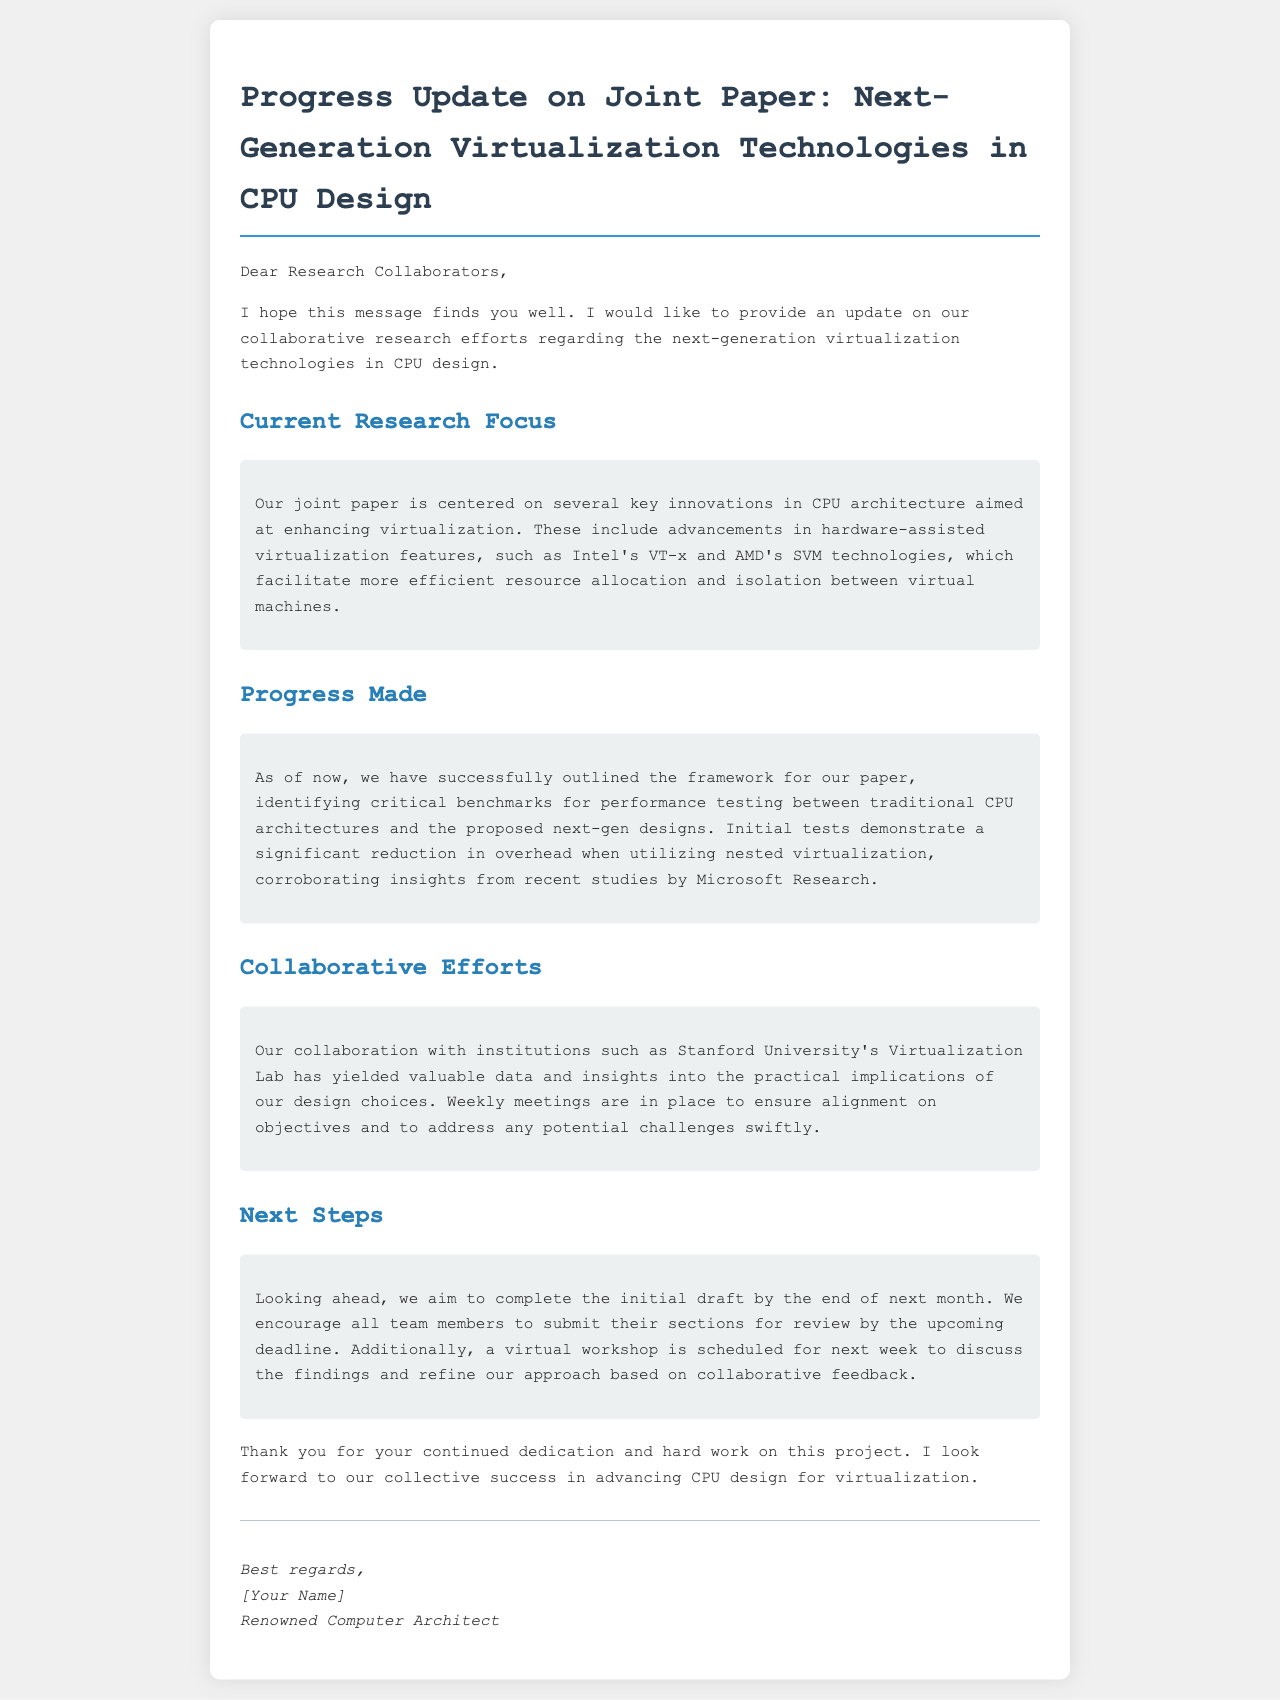What is the main focus of the joint paper? The main focus of the joint paper is on several key innovations in CPU architecture aimed at enhancing virtualization.
Answer: Enhancing virtualization What hardware technologies are discussed in the paper? The document mentions hardware-assisted virtualization features, specifically Intel's VT-x and AMD's SVM technologies.
Answer: Intel's VT-x and AMD's SVM What is the deadline for submitting sections for review? The document states that sections should be submitted by the upcoming deadline, which is the end of next month.
Answer: End of next month Which institution is mentioned as a collaborator? The email references collaboration with Stanford University's Virtualization Lab to gather data and insights.
Answer: Stanford University's Virtualization Lab What significant finding was noted in the initial tests? The initial tests demonstrated a significant reduction in overhead when utilizing nested virtualization.
Answer: Significant reduction in overhead When is the scheduled virtual workshop? The document specifies that a virtual workshop is scheduled for next week.
Answer: Next week How are progress meetings organized among collaborators? The email mentions that weekly meetings are in place to ensure alignment on objectives and address challenges.
Answer: Weekly meetings Who is the author of the email? The email concludes with a signature indicating the author's title and identity.
Answer: [Your Name], Renowned Computer Architect 